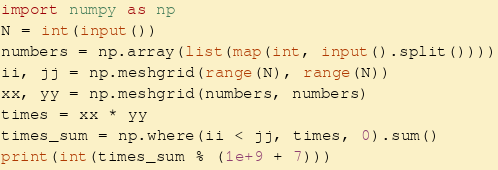Convert code to text. <code><loc_0><loc_0><loc_500><loc_500><_Python_>import numpy as np
N = int(input())
numbers = np.array(list(map(int, input().split())))
ii, jj = np.meshgrid(range(N), range(N))
xx, yy = np.meshgrid(numbers, numbers)
times = xx * yy
times_sum = np.where(ii < jj, times, 0).sum()
print(int(times_sum % (1e+9 + 7)))
</code> 